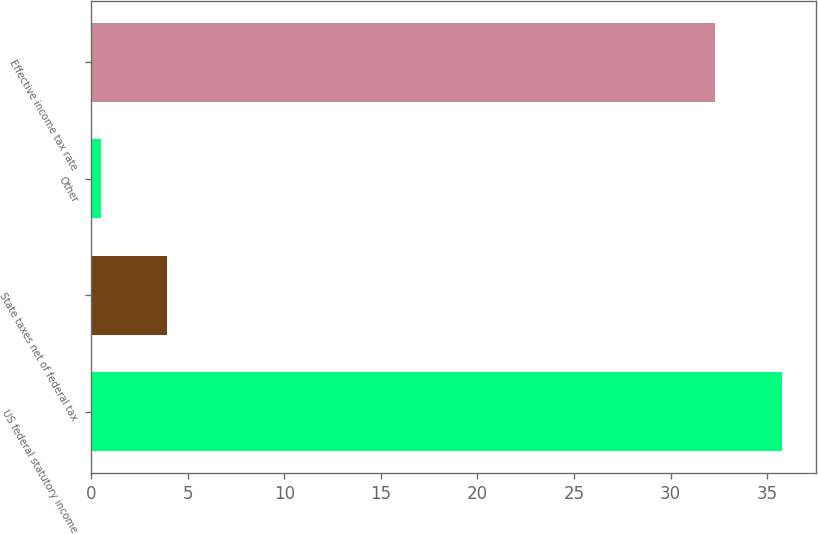<chart> <loc_0><loc_0><loc_500><loc_500><bar_chart><fcel>US federal statutory income<fcel>State taxes net of federal tax<fcel>Other<fcel>Effective income tax rate<nl><fcel>35.75<fcel>3.95<fcel>0.5<fcel>32.3<nl></chart> 